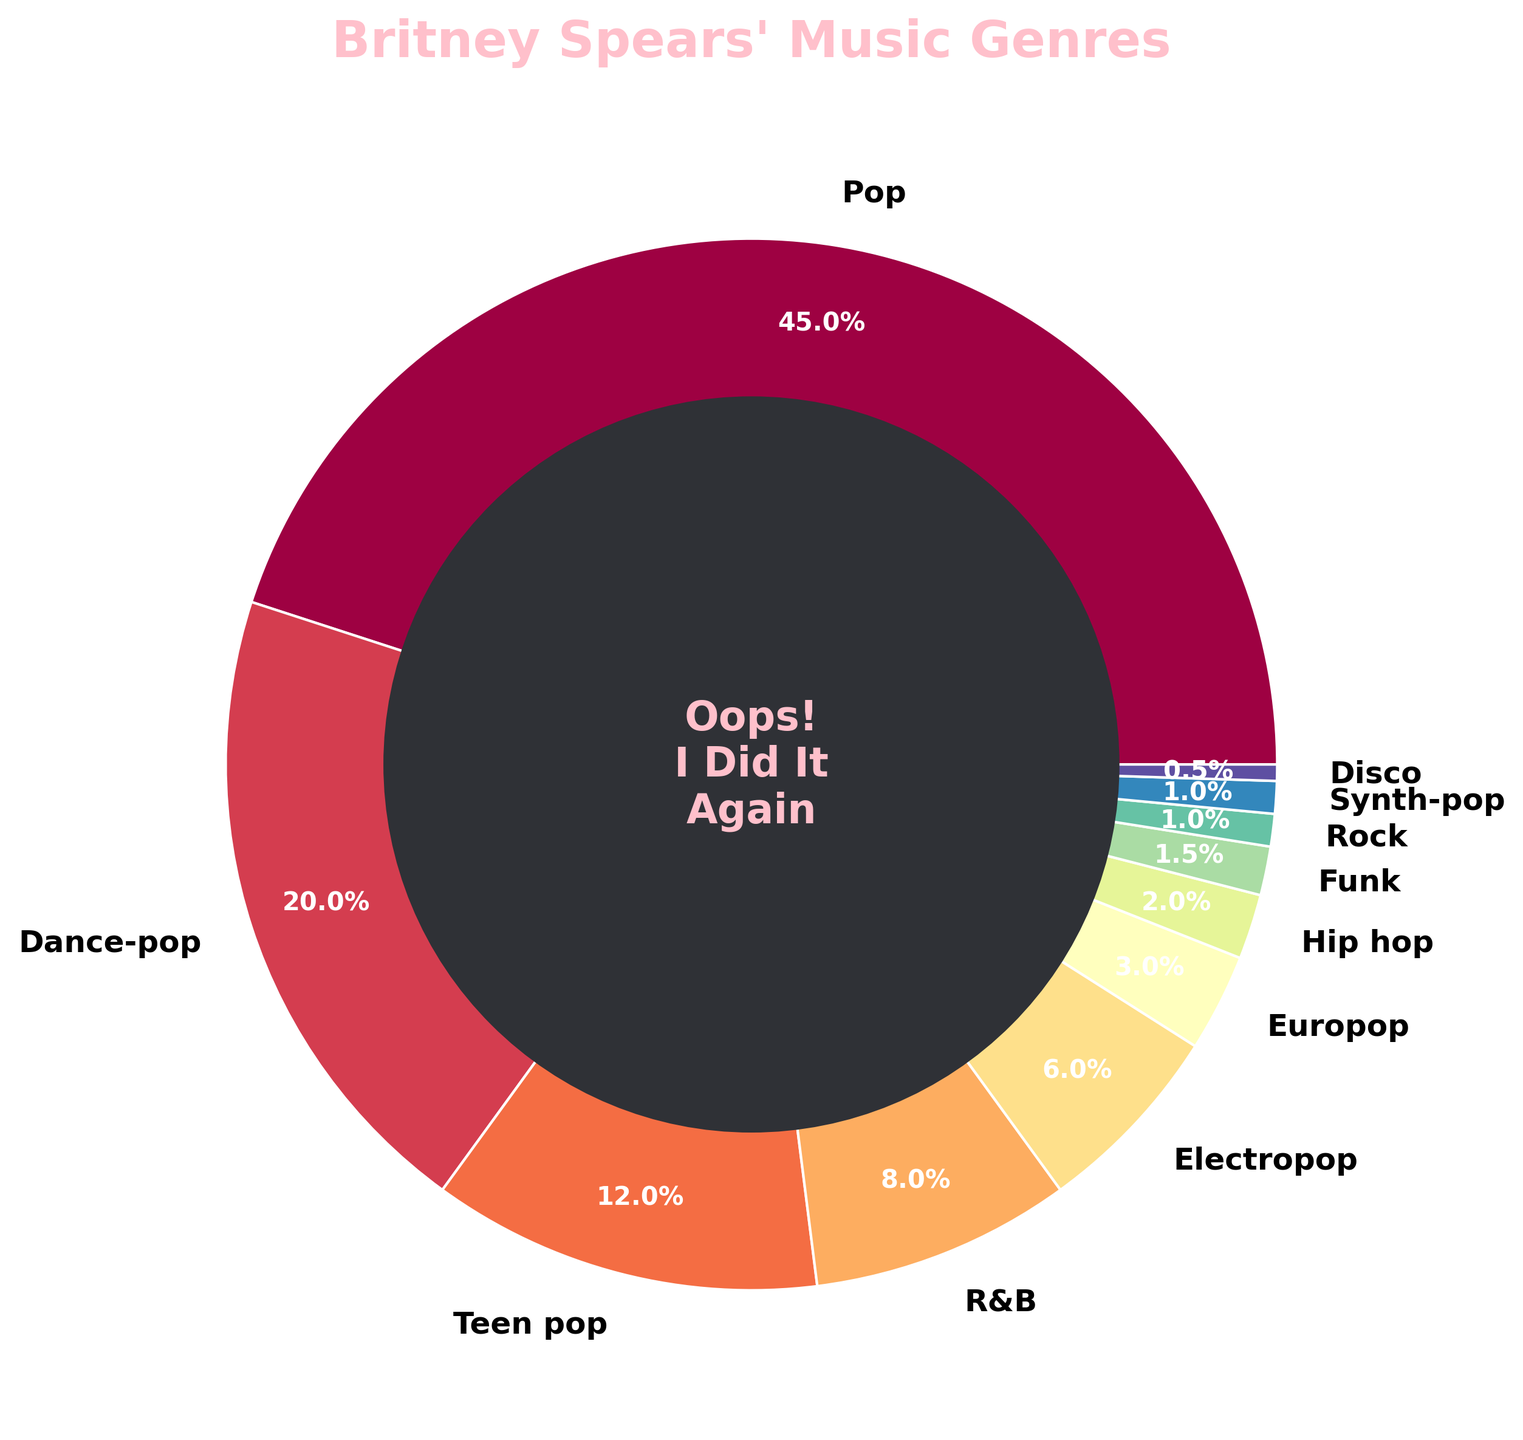What genre has the highest percentage of Britney Spears' songs? The genre with the highest percentage is directly visible at the top of the pie chart. The percentage label shows the value.
Answer: Pop What is the combined percentage of Dance-pop and Teen pop songs? First, identify the percentages of Dance-pop and Teen pop from the pie chart, which are 20% and 12%, respectively. Then, add these values together: 20 + 12 = 32
Answer: 32% Which genre occupies the smallest slice in the pie chart? The smallest slice can be identified visually as the thinnest segment in the chart. According to the labels, this is Disco, which has a percentage of 0.5%.
Answer: Disco Is the percentage of Pop songs more than double the percentage of Dance-pop songs? The percentage of Pop songs is 45%, and the percentage of Dance-pop is 20%. Double the percentage of Dance-pop is 20 * 2 = 40, so 45 is indeed more than 40.
Answer: Yes What is the percentage difference between R&B and Electropop songs? Locate the percentages for R&B and Electropop, which are 8% and 6% respectively. Subtract Electropop from R&B: 8 - 6 = 2. The difference is 2%.
Answer: 2% Are there more genres with percentages above 10% or below 10%? Count the genres with percentages above and below 10% from the pie chart segments. Above 10%: Pop, Dance-pop, Teen pop (3 genres). Below 10%: R&B, Electropop, Europop, Hip hop, Funk, Rock, Synth-pop, Disco (8 genres).
Answer: Below 10% Which genres combined have a percentage equal to that of Pop songs? Identify genres that when summed together equal Pop's 45%: Dance-pop (20%) + Teen pop (12%) + R&B (8%) + Electropop (6%) = 20+12+8+6 = 46 (which is close). Adjust by including a smaller percentage: Dance-pop + Teen pop + R&B + Electropop + Europop (3%) = 20+12+8+6+3 = 49, which slightly exceeds 45%.
Answer: Dance-pop, Teen pop, R&B, and Electropop are close If you sum up the percentages of Hip hop, Funk, Rock, and Synth-pop, do you get more or less than 5%? Find the percentages for Hip hop (2%), Funk (1.5%), Rock (1%), and Synth-pop (1%), then add them up: 2+1.5+1+1 = 5.5%, which is more than 5%.
Answer: More What color represents Teen pop in the pie chart? The color for Teen pop can be identified visually from the chart. Teen pop is usually marked with one of the medium segments and could be seen as a specific shade. Confirm by cross-referencing the color with the label.
Answer: (Provide the specific color observed, e.g., light green) Which genre slice is immediately next to the Pop slice visually? Visually inspect which genre segment is placed adjacent to the Pop slice in the pie chart. These segments are next to the largest slice.
Answer: (Provide the specific genre observed, e.g., Dance-pop) 